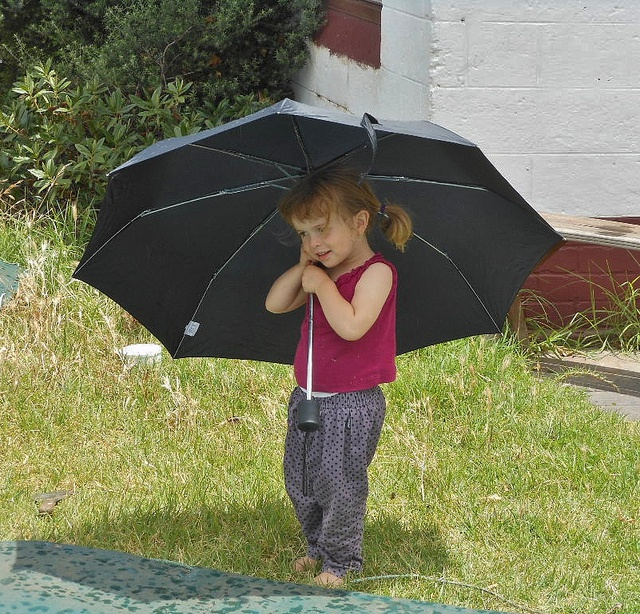Describe the objects in this image and their specific colors. I can see umbrella in black, darkgray, and gray tones and people in black, gray, brown, and maroon tones in this image. 